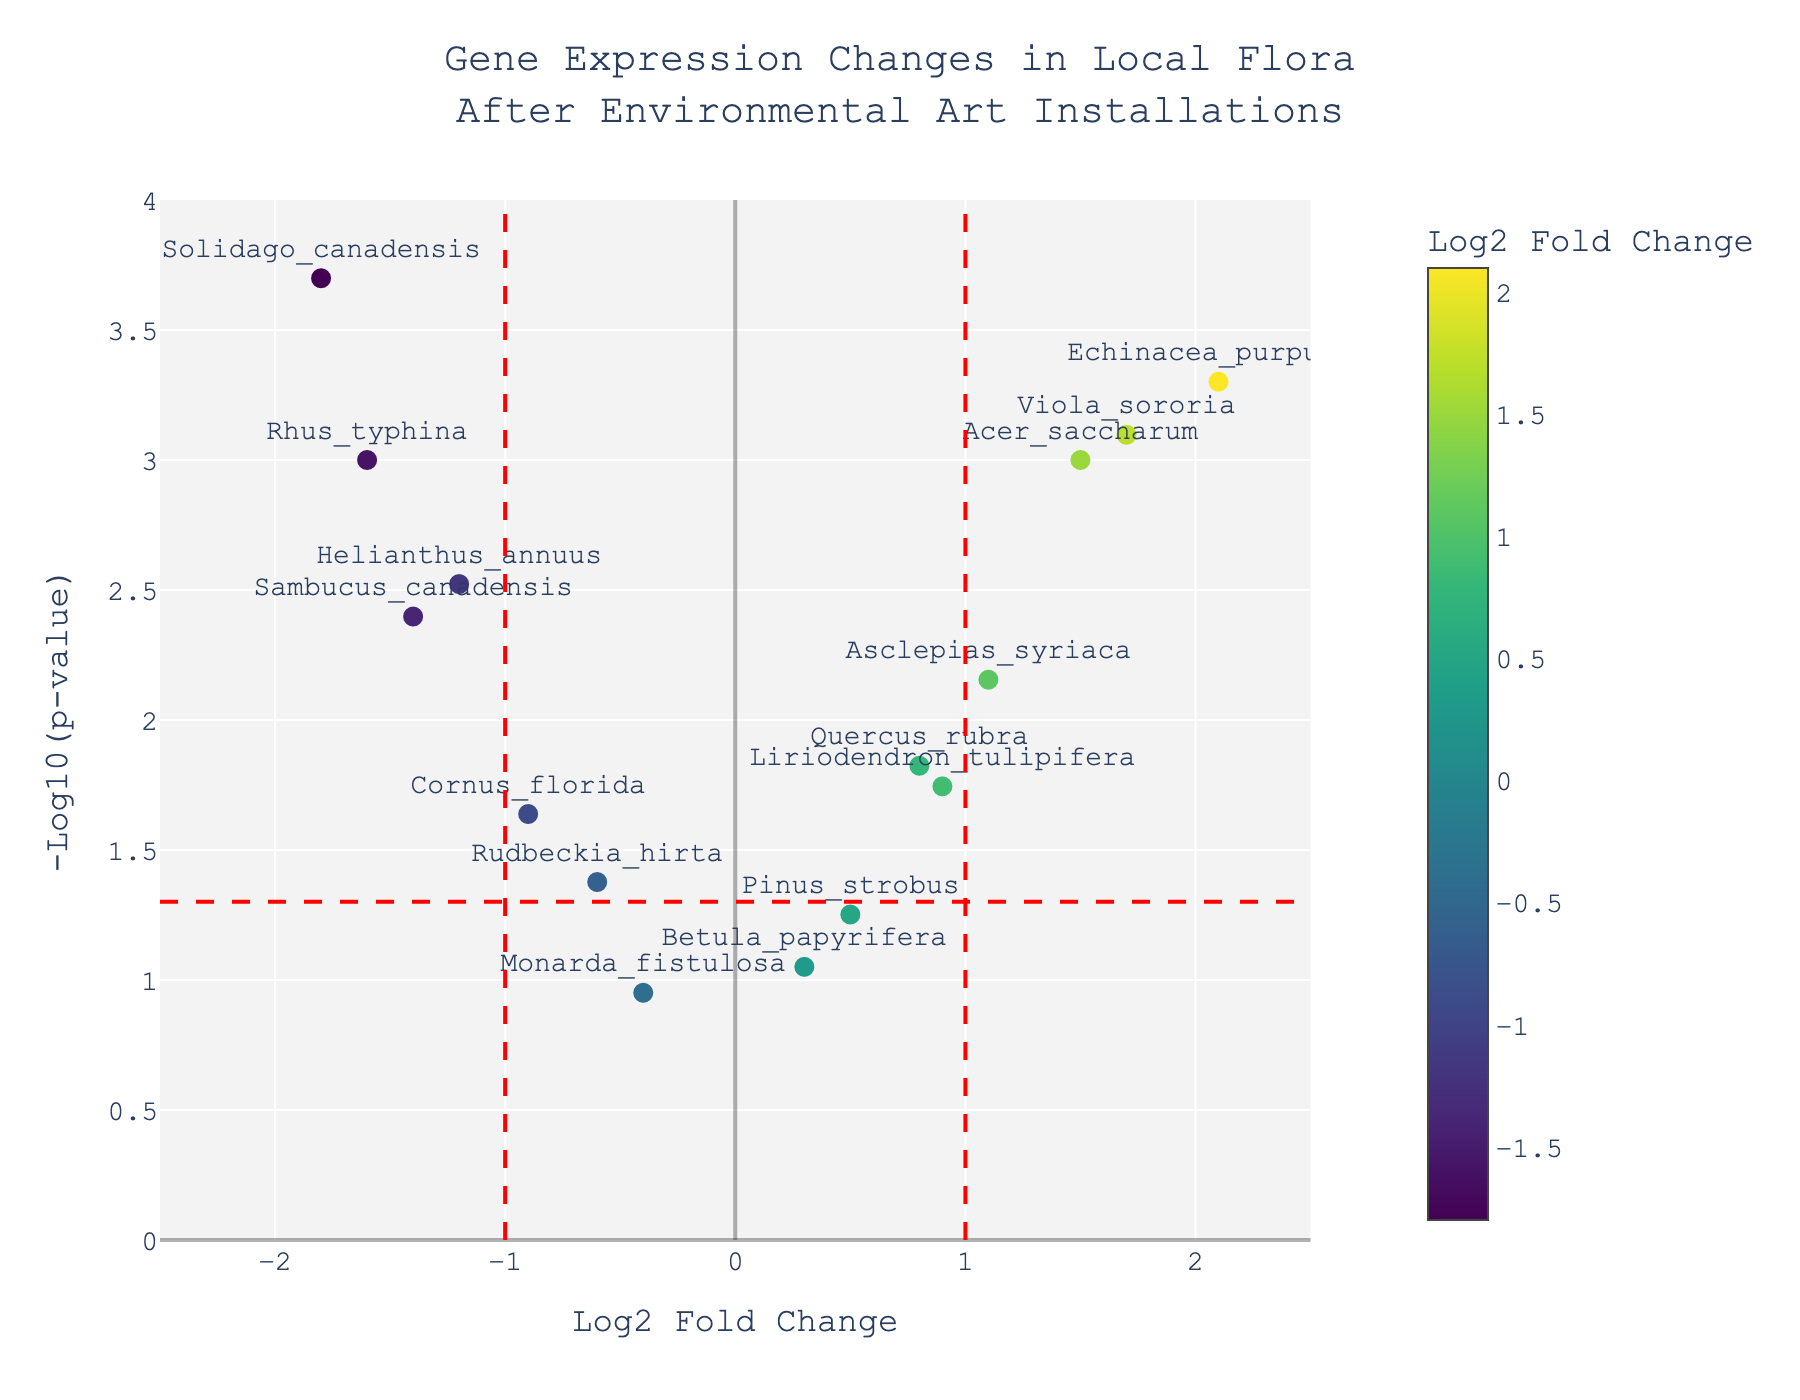How many genes show a significant change in expression (either positive or negative)? Significant changes in gene expression are generally considered to have a p-value less than 0.05. Look for points above the horizontal red dashed line, which represents the threshold of -log10(0.05). Count the points above this line. The genes are Helianthus_annuus, Quercus_rubra, Acer_saccharum, Echinacea_purpurea, Solidago_canadensis, Asclepias_syriaca, Cornus_florida, Sambucus_canadensis, Viola_sororia, and Rhus_typhina.
Answer: 10 Which gene shows the largest positive expression change? Look for the gene with the highest log2 fold change (x-axis) among the data points. The gene Echinacea_purpurea has the highest log2 fold change of 2.1.
Answer: Echinacea_purpurea Which gene has the smallest p-value? The gene with the smallest p-value will have the highest -log10(p-value) on the y-axis. The largest value on the y-axis is for Solidago_canadensis.
Answer: Solidago_canadensis Are there any genes with a p-value greater than 0.1? Look for data points that are below the y-axis value of -log10(0.1). The closer to the x-axis (lower y-value), the higher the p-value. The gene Monarda_fistulosa has a p-value greater than 0.1.
Answer: Monarda_fistulosa What is the log2 fold change threshold for significant expression changes? The vertical dashed red lines represent the thresholds for significant expression changes. Check their positions on the x-axis, which are at -1 and 1.
Answer: ±1 Which gene has the lowest negative log2 fold change, and what is its p-value? Among the genes with negative log2 fold changes (left of the y-axis), identify the one closest to zero and check its p-value. Rudbeckia_hirta has the lowest negative log2 fold change of -0.6 and its p-value is 0.042.
Answer: Rudbeckia_hirta, 0.042 How many genes have a log2 fold change greater than 1.5? Look for points to the right of the x-axis value 1.5. There are two data points within this range, Acer_saccharum and Viola_sororia.
Answer: 2 Which gene is closest to the intersection of the log2 fold change threshold and p-value threshold lines? Identify the gene closest to the intersection of the vertical dashed red line at 1 and the horizontal dashed red line at -log10(0.05). The gene Acer_saccharum is closest to this intersection.
Answer: Acer_saccharum Are any genes identified with a significant decrease in expression? If so, which one has the greatest decrease? Significant decreases in expression will be to the left of the vertical dashed red line at -1 and above the horizontal dashed red line for -log10(0.05). The most significant decrease is Solidago_canadensis with a log2 fold change of -1.8 and the smallest p-value (highest -log10(p-value)).
Answer: Solidago_canadensis 